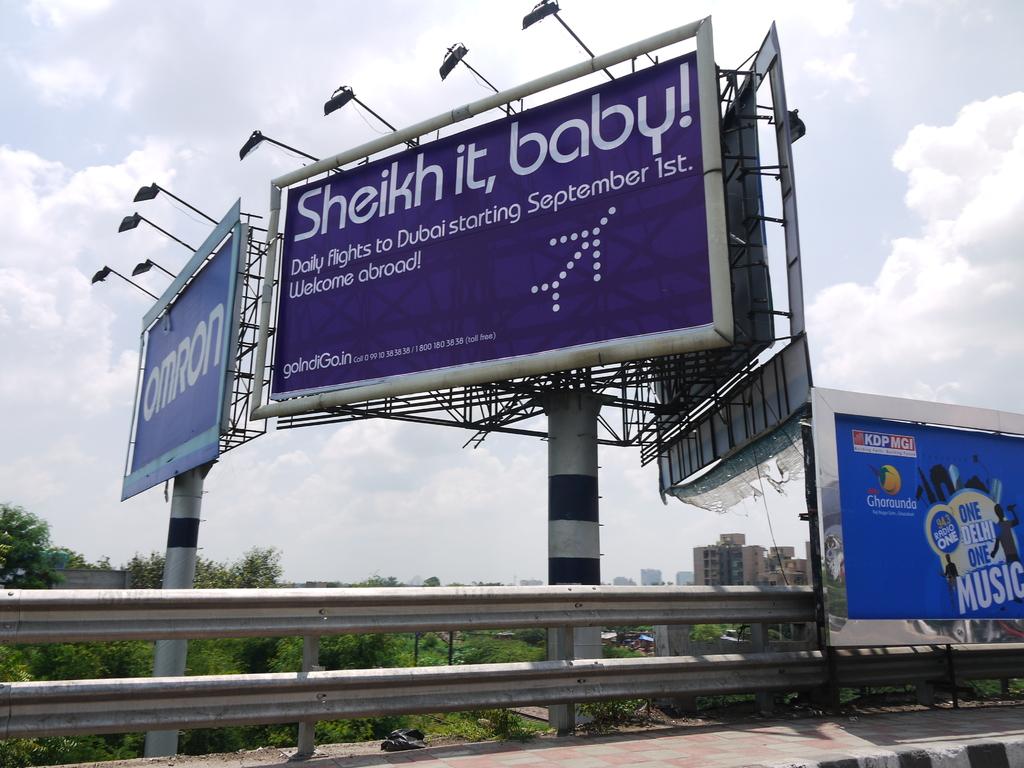What is on the billboard?
Ensure brevity in your answer.  Sheikh it, baby!. 